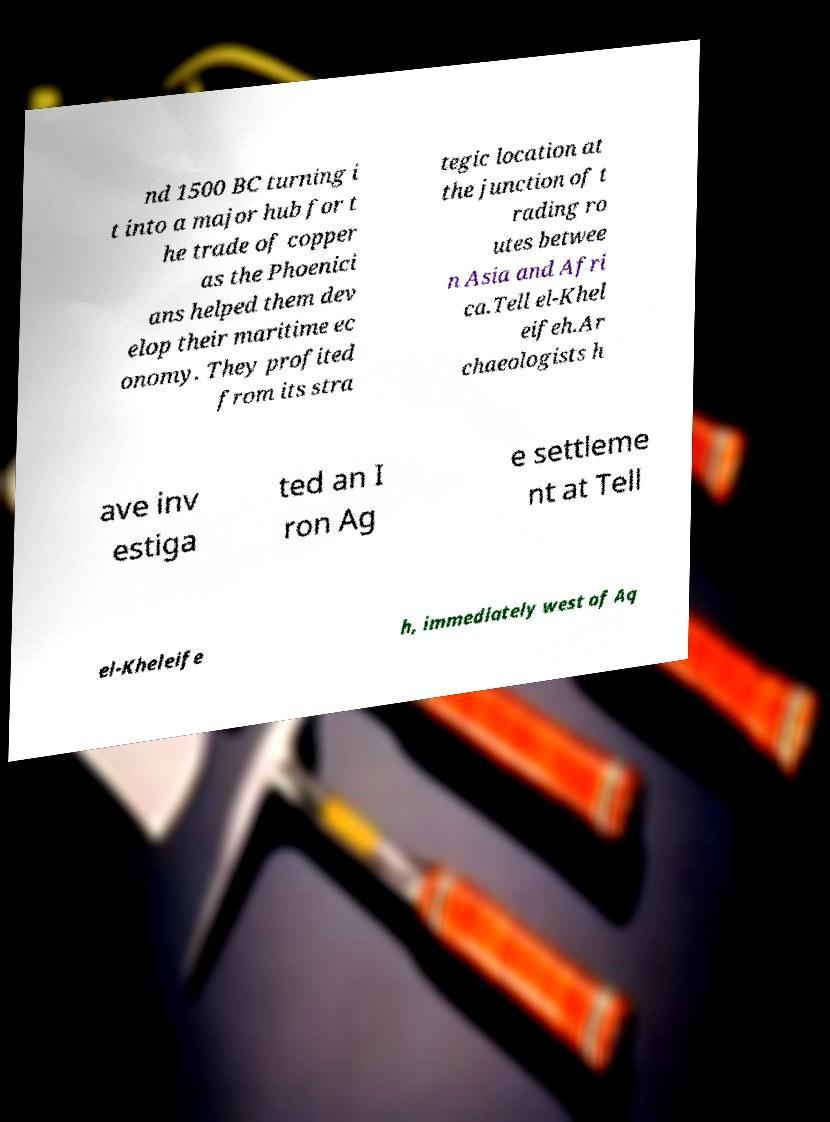Please read and relay the text visible in this image. What does it say? nd 1500 BC turning i t into a major hub for t he trade of copper as the Phoenici ans helped them dev elop their maritime ec onomy. They profited from its stra tegic location at the junction of t rading ro utes betwee n Asia and Afri ca.Tell el-Khel eifeh.Ar chaeologists h ave inv estiga ted an I ron Ag e settleme nt at Tell el-Kheleife h, immediately west of Aq 